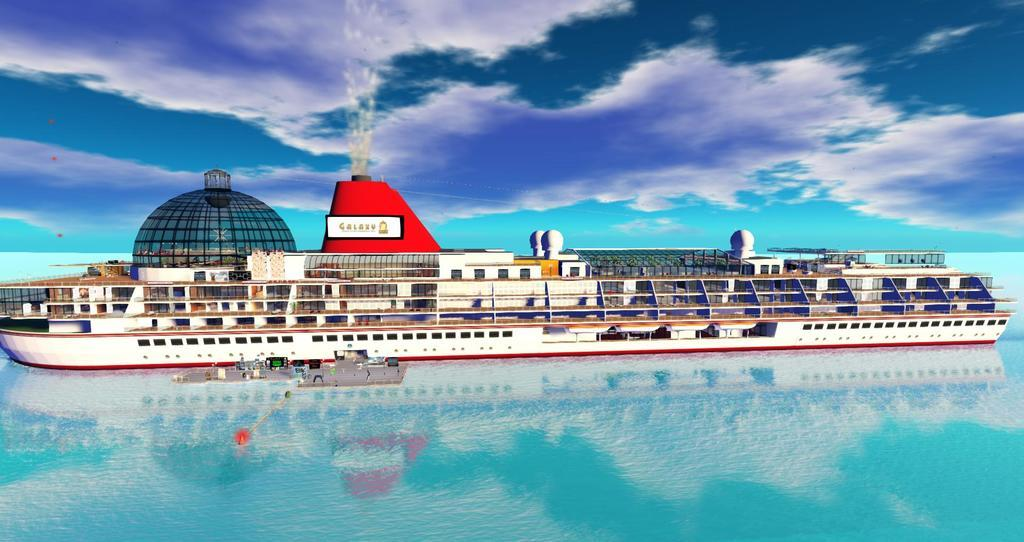What is the main subject of the image? The main subject of the image is a ship. Can you describe the color of the ship? The ship is white. Are there any other ships visible in the image? Yes, there is another ship in front of the first ship. What colors can be seen in the sky in the background? The sky in the background has white, blue, and green colors. What type of dress is the ship wearing in the image? Ships do not wear dresses; they are inanimate objects. 